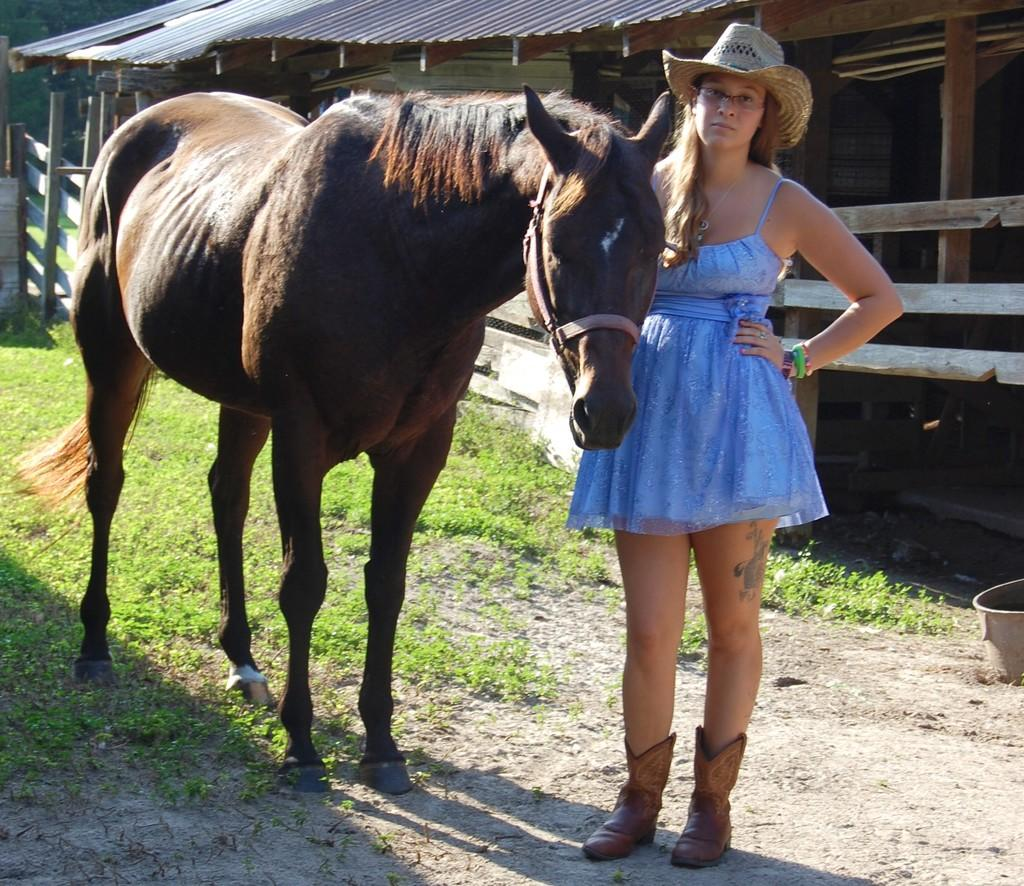What animal is present in the image? There is a horse in the image. Who is with the horse in the image? There is a lady in the image. What is the lady wearing? The lady is wearing a blue gown and a hat. What can be seen in the background of the image? There is a roof-like shade in the background. What is under the horse in the image? There is grass under the horse. What type of pancake is the lady holding in the image? There is no pancake present in the image; the lady is not holding any food item. 